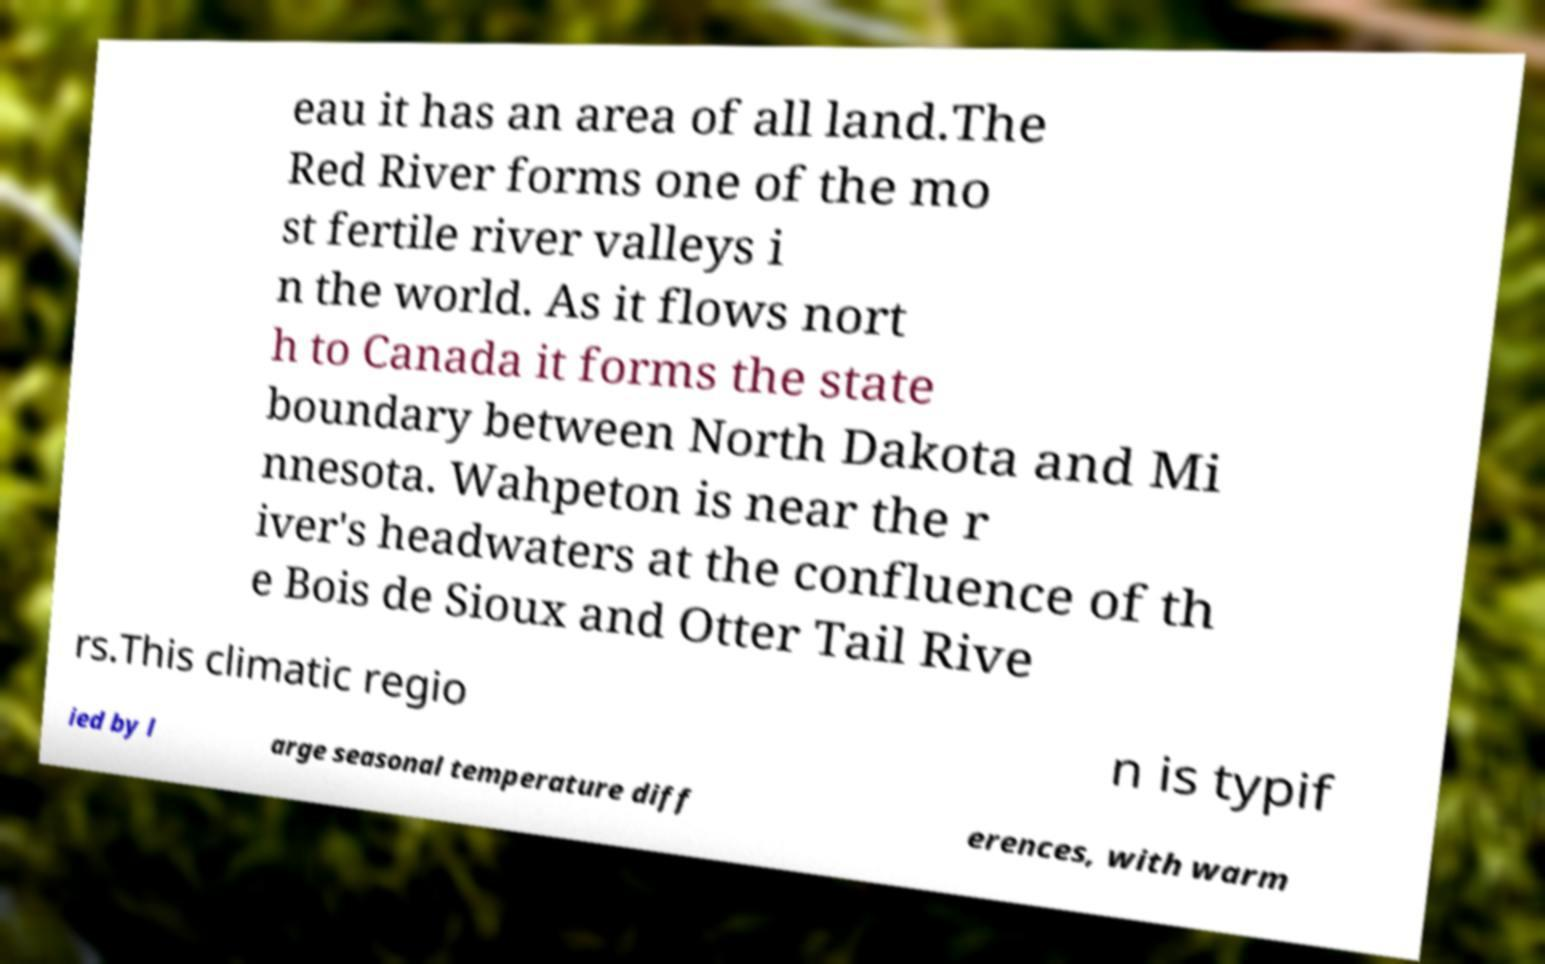Could you extract and type out the text from this image? eau it has an area of all land.The Red River forms one of the mo st fertile river valleys i n the world. As it flows nort h to Canada it forms the state boundary between North Dakota and Mi nnesota. Wahpeton is near the r iver's headwaters at the confluence of th e Bois de Sioux and Otter Tail Rive rs.This climatic regio n is typif ied by l arge seasonal temperature diff erences, with warm 